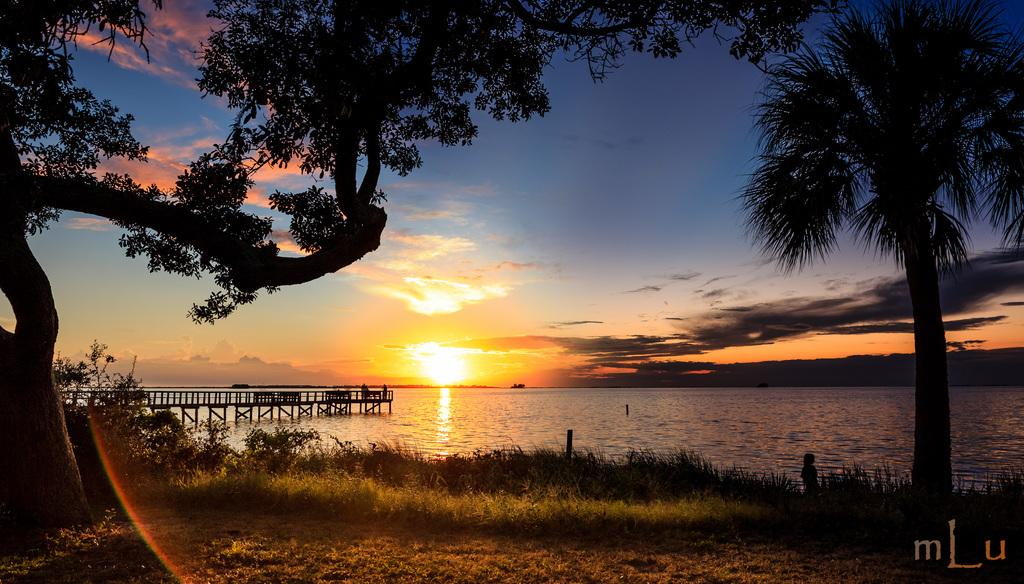What type of vegetation can be seen in the image? There are trees in the image. What body of water is present in the image? There is a lake in the image. What type of ground cover is visible in the image? There is grass in the image. What time of day is depicted in the image? The image depicts a sunset. What part of the natural environment is visible in the image? The sky is visible in the image. What structure is present on the lake in the image? There is a bridge on the lake in the image. What additional feature can be seen at the bottom of the image? A rainbow is present at the bottom of the image. How does the quicksand affect the trees in the image? There is no quicksand present in the image, so it does not affect the trees. What fact can be learned about the image from the provided information? The fact that there is a bridge on the lake can be learned from the provided information. 